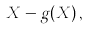<formula> <loc_0><loc_0><loc_500><loc_500>X - g ( X ) \, ,</formula> 